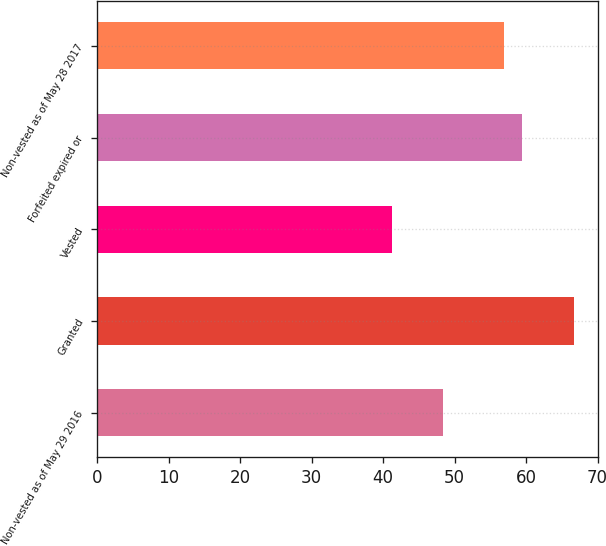Convert chart to OTSL. <chart><loc_0><loc_0><loc_500><loc_500><bar_chart><fcel>Non-vested as of May 29 2016<fcel>Granted<fcel>Vested<fcel>Forfeited expired or<fcel>Non-vested as of May 28 2017<nl><fcel>48.37<fcel>66.75<fcel>41.21<fcel>59.48<fcel>56.93<nl></chart> 